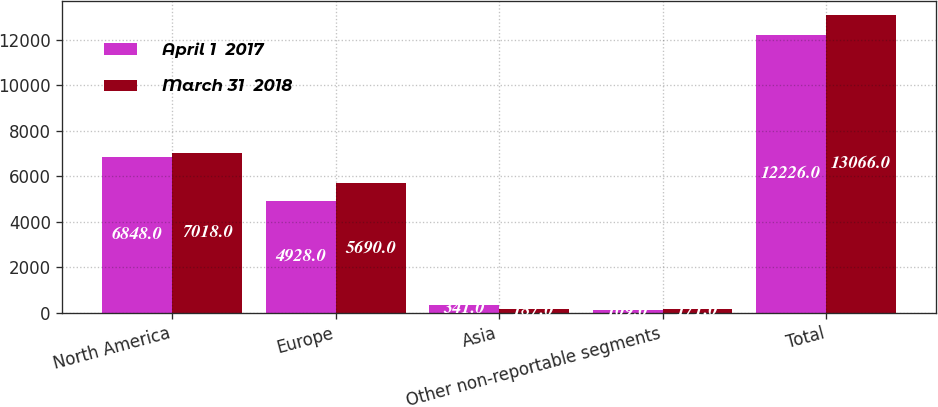Convert chart to OTSL. <chart><loc_0><loc_0><loc_500><loc_500><stacked_bar_chart><ecel><fcel>North America<fcel>Europe<fcel>Asia<fcel>Other non-reportable segments<fcel>Total<nl><fcel>April 1  2017<fcel>6848<fcel>4928<fcel>341<fcel>109<fcel>12226<nl><fcel>March 31  2018<fcel>7018<fcel>5690<fcel>187<fcel>171<fcel>13066<nl></chart> 